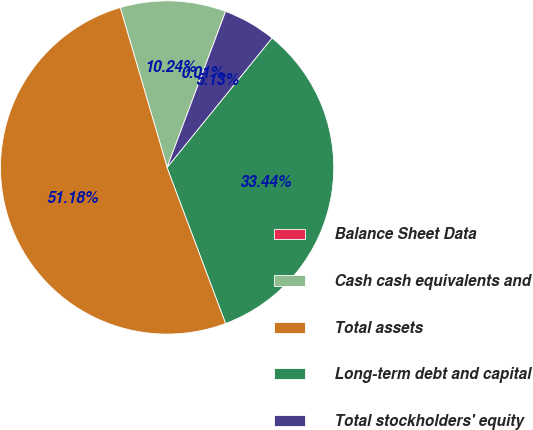Convert chart to OTSL. <chart><loc_0><loc_0><loc_500><loc_500><pie_chart><fcel>Balance Sheet Data<fcel>Cash cash equivalents and<fcel>Total assets<fcel>Long-term debt and capital<fcel>Total stockholders' equity<nl><fcel>0.01%<fcel>10.24%<fcel>51.18%<fcel>33.44%<fcel>5.13%<nl></chart> 